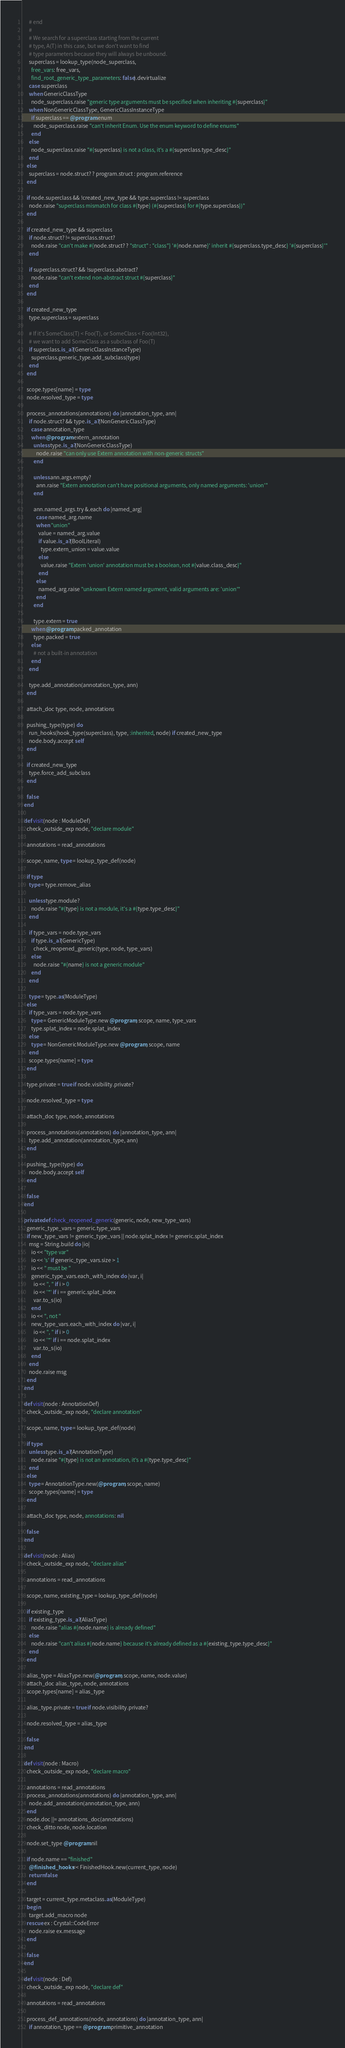Convert code to text. <code><loc_0><loc_0><loc_500><loc_500><_Crystal_>      # end
      #
      # We search for a superclass starting from the current
      # type, A(T) in this case, but we don't want to find
      # type parameters because they will always be unbound.
      superclass = lookup_type(node_superclass,
        free_vars: free_vars,
        find_root_generic_type_parameters: false).devirtualize
      case superclass
      when GenericClassType
        node_superclass.raise "generic type arguments must be specified when inheriting #{superclass}"
      when NonGenericClassType, GenericClassInstanceType
        if superclass == @program.enum
          node_superclass.raise "can't inherit Enum. Use the enum keyword to define enums"
        end
      else
        node_superclass.raise "#{superclass} is not a class, it's a #{superclass.type_desc}"
      end
    else
      superclass = node.struct? ? program.struct : program.reference
    end

    if node.superclass && !created_new_type && type.superclass != superclass
      node.raise "superclass mismatch for class #{type} (#{superclass} for #{type.superclass})"
    end

    if created_new_type && superclass
      if node.struct? != superclass.struct?
        node.raise "can't make #{node.struct? ? "struct" : "class"} '#{node.name}' inherit #{superclass.type_desc} '#{superclass}'"
      end

      if superclass.struct? && !superclass.abstract?
        node.raise "can't extend non-abstract struct #{superclass}"
      end
    end

    if created_new_type
      type.superclass = superclass

      # If it's SomeClass(T) < Foo(T), or SomeClass < Foo(Int32),
      # we want to add SomeClass as a subclass of Foo(T)
      if superclass.is_a?(GenericClassInstanceType)
        superclass.generic_type.add_subclass(type)
      end
    end

    scope.types[name] = type
    node.resolved_type = type

    process_annotations(annotations) do |annotation_type, ann|
      if node.struct? && type.is_a?(NonGenericClassType)
        case annotation_type
        when @program.extern_annotation
          unless type.is_a?(NonGenericClassType)
            node.raise "can only use Extern annotation with non-generic structs"
          end

          unless ann.args.empty?
            ann.raise "Extern annotation can't have positional arguments, only named arguments: 'union'"
          end

          ann.named_args.try &.each do |named_arg|
            case named_arg.name
            when "union"
              value = named_arg.value
              if value.is_a?(BoolLiteral)
                type.extern_union = value.value
              else
                value.raise "Extern 'union' annotation must be a boolean, not #{value.class_desc}"
              end
            else
              named_arg.raise "unknown Extern named argument, valid arguments are: 'union'"
            end
          end

          type.extern = true
        when @program.packed_annotation
          type.packed = true
        else
          # not a built-in annotation
        end
      end

      type.add_annotation(annotation_type, ann)
    end

    attach_doc type, node, annotations

    pushing_type(type) do
      run_hooks(hook_type(superclass), type, :inherited, node) if created_new_type
      node.body.accept self
    end

    if created_new_type
      type.force_add_subclass
    end

    false
  end

  def visit(node : ModuleDef)
    check_outside_exp node, "declare module"

    annotations = read_annotations

    scope, name, type = lookup_type_def(node)

    if type
      type = type.remove_alias

      unless type.module?
        node.raise "#{type} is not a module, it's a #{type.type_desc}"
      end

      if type_vars = node.type_vars
        if type.is_a?(GenericType)
          check_reopened_generic(type, node, type_vars)
        else
          node.raise "#{name} is not a generic module"
        end
      end

      type = type.as(ModuleType)
    else
      if type_vars = node.type_vars
        type = GenericModuleType.new @program, scope, name, type_vars
        type.splat_index = node.splat_index
      else
        type = NonGenericModuleType.new @program, scope, name
      end
      scope.types[name] = type
    end

    type.private = true if node.visibility.private?

    node.resolved_type = type

    attach_doc type, node, annotations

    process_annotations(annotations) do |annotation_type, ann|
      type.add_annotation(annotation_type, ann)
    end

    pushing_type(type) do
      node.body.accept self
    end

    false
  end

  private def check_reopened_generic(generic, node, new_type_vars)
    generic_type_vars = generic.type_vars
    if new_type_vars != generic_type_vars || node.splat_index != generic.splat_index
      msg = String.build do |io|
        io << "type var"
        io << 's' if generic_type_vars.size > 1
        io << " must be "
        generic_type_vars.each_with_index do |var, i|
          io << ", " if i > 0
          io << '*' if i == generic.splat_index
          var.to_s(io)
        end
        io << ", not "
        new_type_vars.each_with_index do |var, i|
          io << ", " if i > 0
          io << '*' if i == node.splat_index
          var.to_s(io)
        end
      end
      node.raise msg
    end
  end

  def visit(node : AnnotationDef)
    check_outside_exp node, "declare annotation"

    scope, name, type = lookup_type_def(node)

    if type
      unless type.is_a?(AnnotationType)
        node.raise "#{type} is not an annotation, it's a #{type.type_desc}"
      end
    else
      type = AnnotationType.new(@program, scope, name)
      scope.types[name] = type
    end

    attach_doc type, node, annotations: nil

    false
  end

  def visit(node : Alias)
    check_outside_exp node, "declare alias"

    annotations = read_annotations

    scope, name, existing_type = lookup_type_def(node)

    if existing_type
      if existing_type.is_a?(AliasType)
        node.raise "alias #{node.name} is already defined"
      else
        node.raise "can't alias #{node.name} because it's already defined as a #{existing_type.type_desc}"
      end
    end

    alias_type = AliasType.new(@program, scope, name, node.value)
    attach_doc alias_type, node, annotations
    scope.types[name] = alias_type

    alias_type.private = true if node.visibility.private?

    node.resolved_type = alias_type

    false
  end

  def visit(node : Macro)
    check_outside_exp node, "declare macro"

    annotations = read_annotations
    process_annotations(annotations) do |annotation_type, ann|
      node.add_annotation(annotation_type, ann)
    end
    node.doc ||= annotations_doc(annotations)
    check_ditto node, node.location

    node.set_type @program.nil

    if node.name == "finished"
      @finished_hooks << FinishedHook.new(current_type, node)
      return false
    end

    target = current_type.metaclass.as(ModuleType)
    begin
      target.add_macro node
    rescue ex : Crystal::CodeError
      node.raise ex.message
    end

    false
  end

  def visit(node : Def)
    check_outside_exp node, "declare def"

    annotations = read_annotations

    process_def_annotations(node, annotations) do |annotation_type, ann|
      if annotation_type == @program.primitive_annotation</code> 